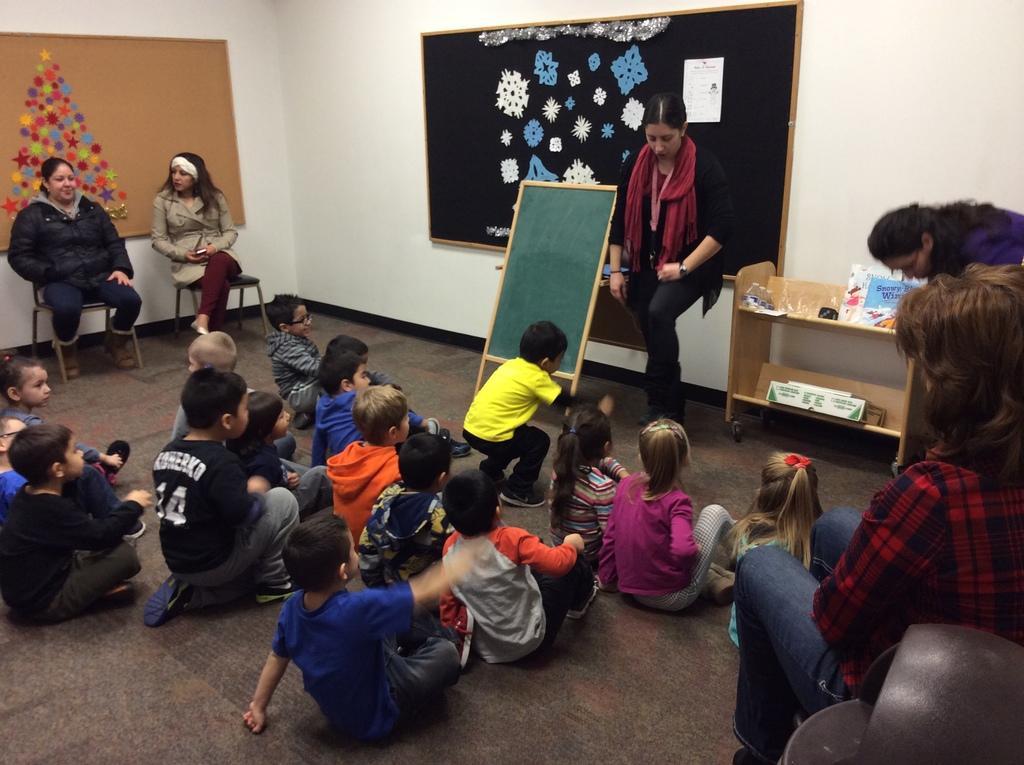Can you describe this image briefly? There are group of children and three women sitting. I can see a boy and a woman standing. These are the notice boards, which are attached to the walls. This is a green board. I can see a wooden rack with few objects in it. 